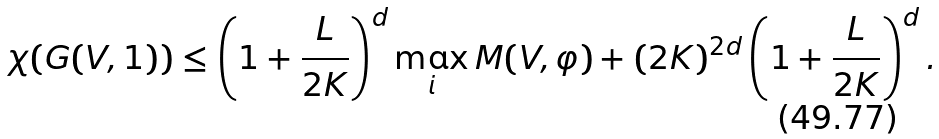Convert formula to latex. <formula><loc_0><loc_0><loc_500><loc_500>\chi ( G ( V , 1 ) ) \leq \left ( 1 + \frac { L } { 2 K } \right ) ^ { d } \max _ { i } M ( V , \varphi ) + ( 2 K ) ^ { 2 d } \left ( 1 + \frac { L } { 2 K } \right ) ^ { d } .</formula> 